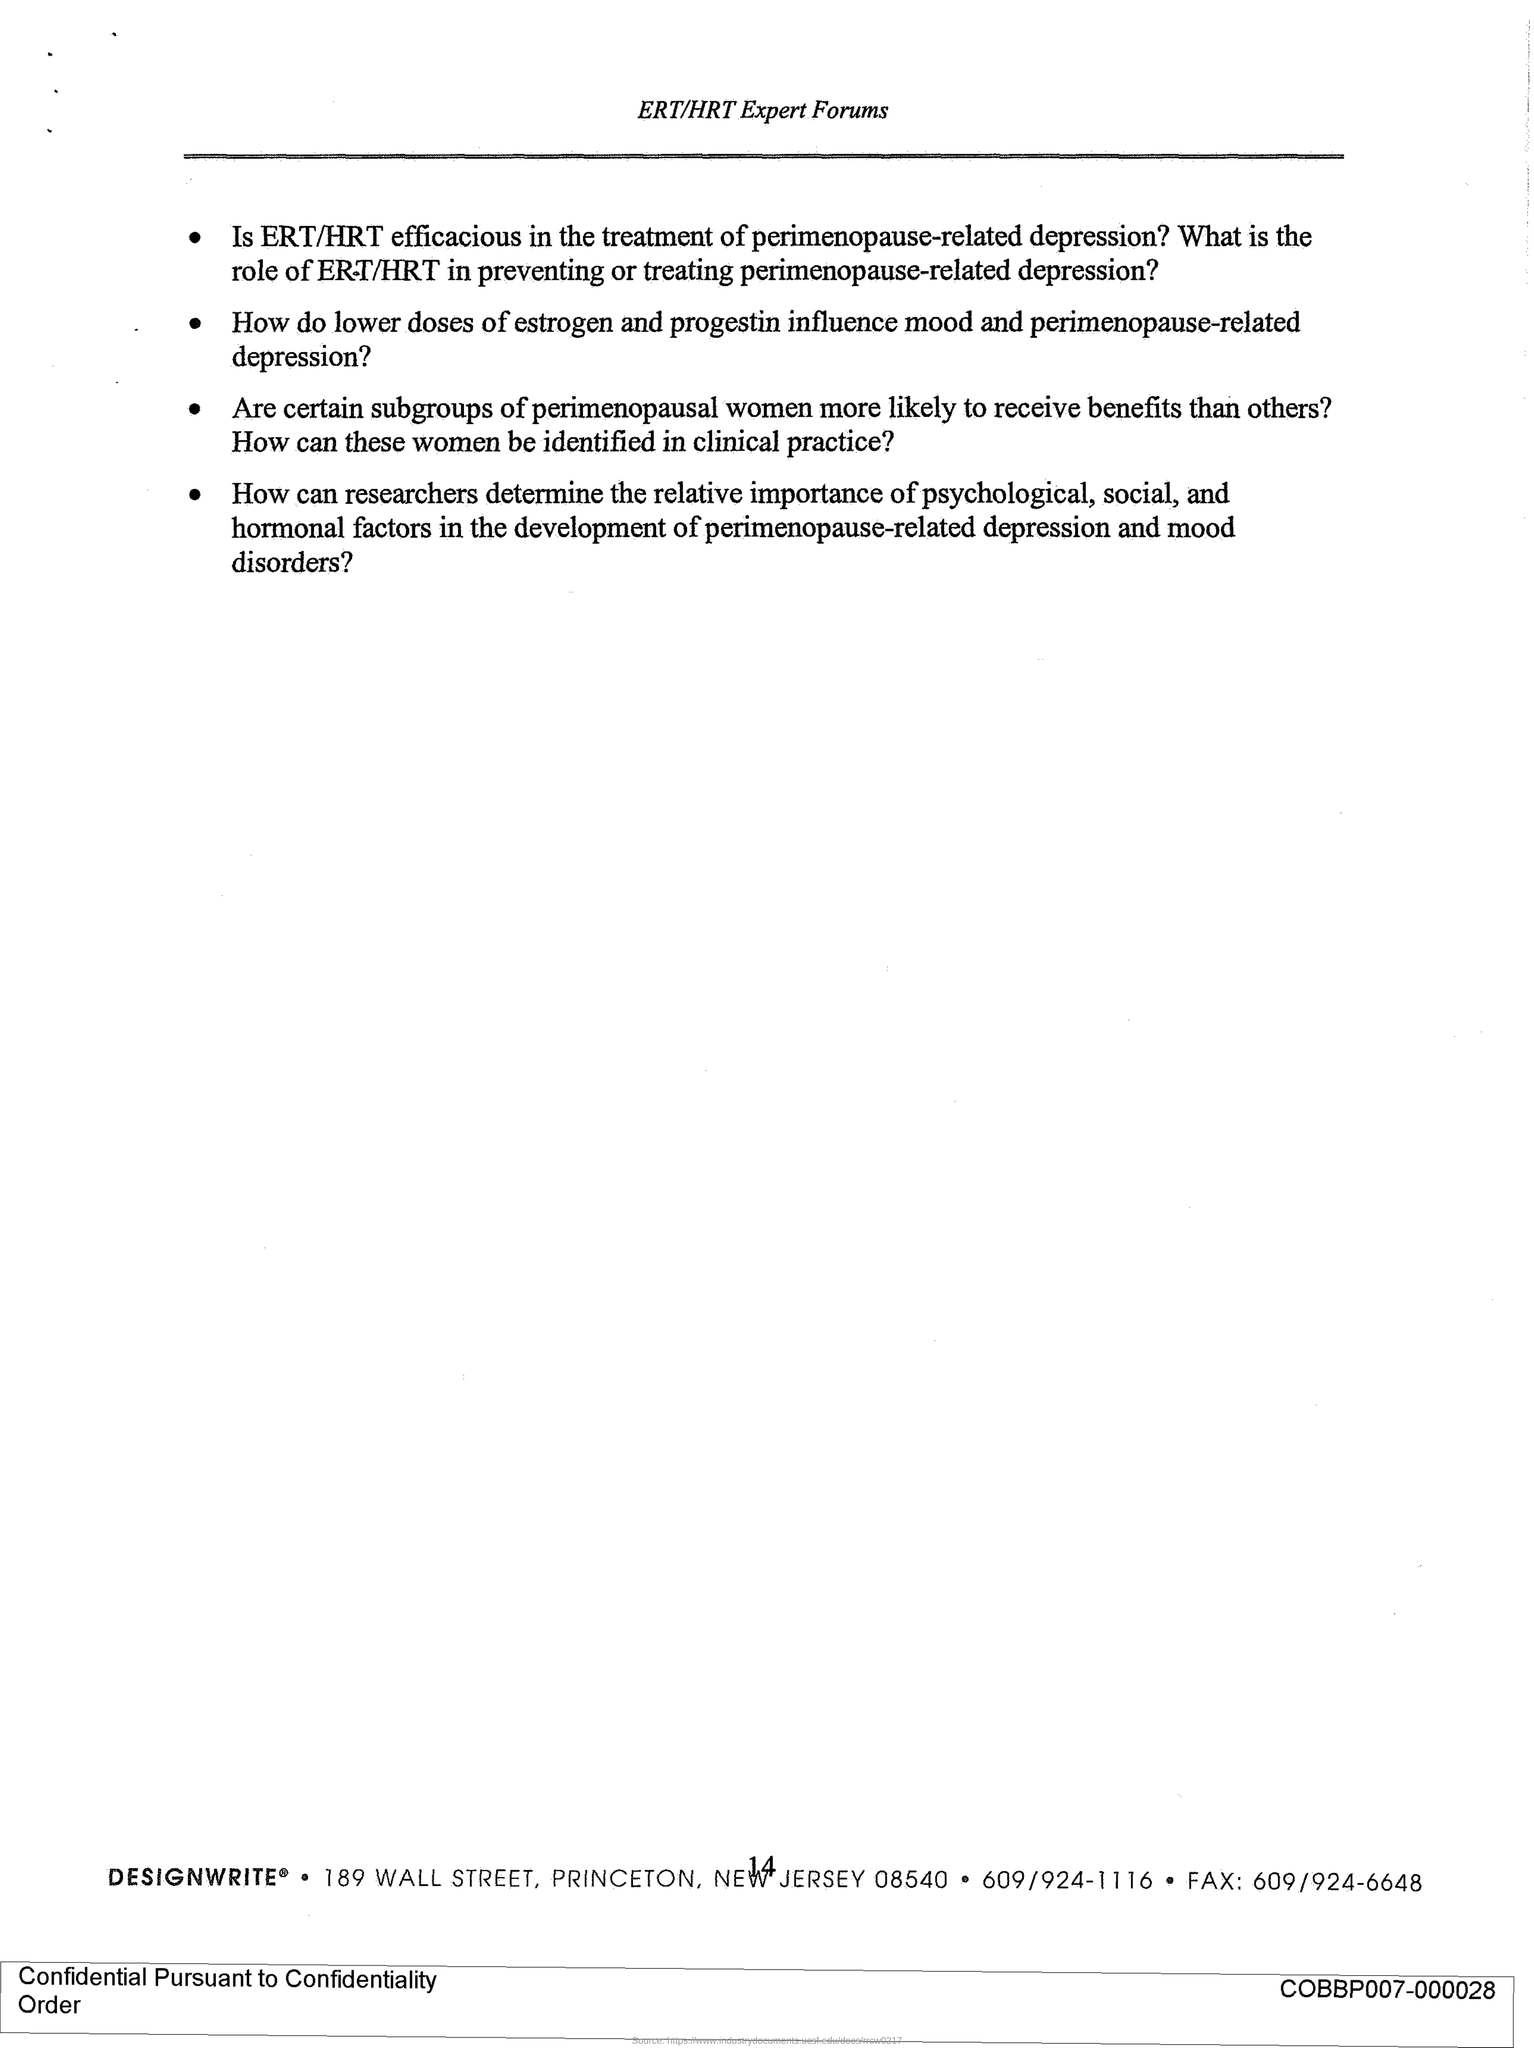Draw attention to some important aspects in this diagram. The page number is 14. The fax number is 609/924-6648. 